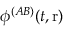Convert formula to latex. <formula><loc_0><loc_0><loc_500><loc_500>\phi ^ { ( A B ) } ( t , r )</formula> 